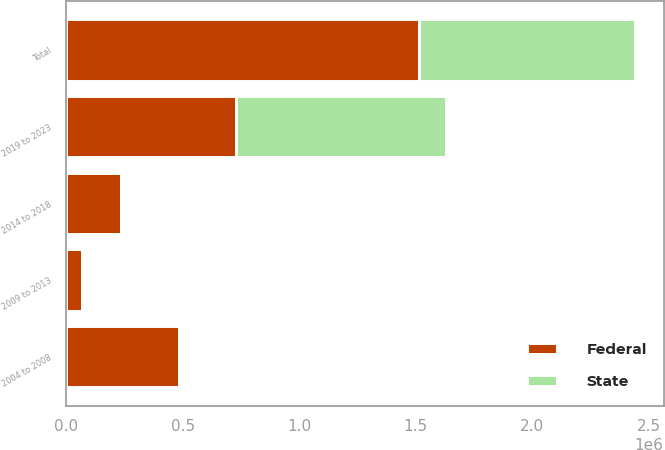Convert chart to OTSL. <chart><loc_0><loc_0><loc_500><loc_500><stacked_bar_chart><ecel><fcel>2004 to 2008<fcel>2009 to 2013<fcel>2014 to 2018<fcel>2019 to 2023<fcel>Total<nl><fcel>State<fcel>1451<fcel>12234<fcel>10191<fcel>903010<fcel>926886<nl><fcel>Federal<fcel>483578<fcel>66666<fcel>235589<fcel>728139<fcel>1.51397e+06<nl></chart> 